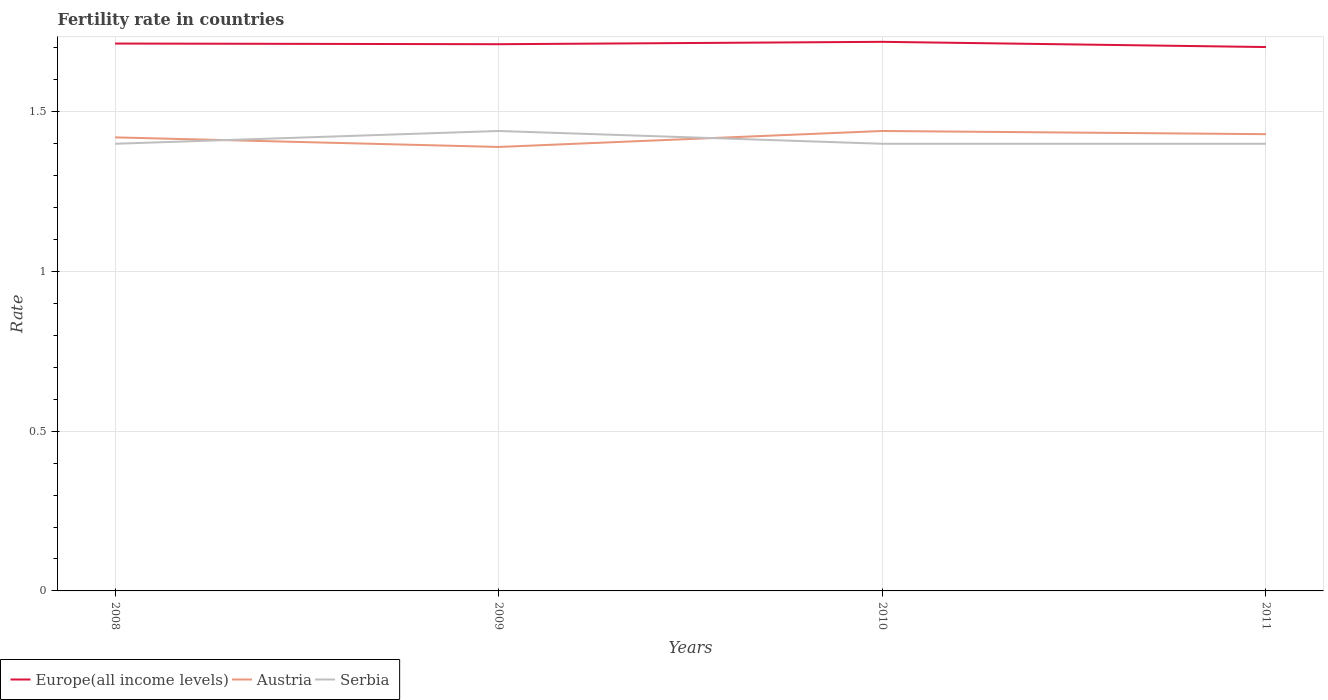Is the number of lines equal to the number of legend labels?
Give a very brief answer. Yes. Across all years, what is the maximum fertility rate in Europe(all income levels)?
Provide a succinct answer. 1.7. What is the total fertility rate in Austria in the graph?
Offer a very short reply. -0.01. What is the difference between the highest and the second highest fertility rate in Serbia?
Your answer should be compact. 0.04. What is the difference between the highest and the lowest fertility rate in Serbia?
Your answer should be compact. 1. How many lines are there?
Your answer should be compact. 3. Does the graph contain any zero values?
Your answer should be compact. No. Does the graph contain grids?
Give a very brief answer. Yes. Where does the legend appear in the graph?
Ensure brevity in your answer.  Bottom left. How many legend labels are there?
Provide a succinct answer. 3. How are the legend labels stacked?
Make the answer very short. Horizontal. What is the title of the graph?
Your response must be concise. Fertility rate in countries. What is the label or title of the X-axis?
Provide a short and direct response. Years. What is the label or title of the Y-axis?
Give a very brief answer. Rate. What is the Rate in Europe(all income levels) in 2008?
Offer a terse response. 1.71. What is the Rate of Austria in 2008?
Offer a very short reply. 1.42. What is the Rate of Europe(all income levels) in 2009?
Keep it short and to the point. 1.71. What is the Rate of Austria in 2009?
Offer a very short reply. 1.39. What is the Rate in Serbia in 2009?
Offer a terse response. 1.44. What is the Rate of Europe(all income levels) in 2010?
Provide a short and direct response. 1.72. What is the Rate of Austria in 2010?
Ensure brevity in your answer.  1.44. What is the Rate of Europe(all income levels) in 2011?
Make the answer very short. 1.7. What is the Rate of Austria in 2011?
Offer a very short reply. 1.43. Across all years, what is the maximum Rate of Europe(all income levels)?
Ensure brevity in your answer.  1.72. Across all years, what is the maximum Rate in Austria?
Your answer should be very brief. 1.44. Across all years, what is the maximum Rate of Serbia?
Offer a terse response. 1.44. Across all years, what is the minimum Rate in Europe(all income levels)?
Provide a short and direct response. 1.7. Across all years, what is the minimum Rate in Austria?
Keep it short and to the point. 1.39. Across all years, what is the minimum Rate of Serbia?
Give a very brief answer. 1.4. What is the total Rate of Europe(all income levels) in the graph?
Your answer should be very brief. 6.85. What is the total Rate of Austria in the graph?
Offer a very short reply. 5.68. What is the total Rate of Serbia in the graph?
Offer a very short reply. 5.64. What is the difference between the Rate of Europe(all income levels) in 2008 and that in 2009?
Your answer should be very brief. 0. What is the difference between the Rate in Serbia in 2008 and that in 2009?
Your answer should be very brief. -0.04. What is the difference between the Rate of Europe(all income levels) in 2008 and that in 2010?
Give a very brief answer. -0.01. What is the difference between the Rate of Austria in 2008 and that in 2010?
Offer a terse response. -0.02. What is the difference between the Rate of Europe(all income levels) in 2008 and that in 2011?
Provide a succinct answer. 0.01. What is the difference between the Rate of Austria in 2008 and that in 2011?
Provide a succinct answer. -0.01. What is the difference between the Rate of Serbia in 2008 and that in 2011?
Provide a short and direct response. 0. What is the difference between the Rate in Europe(all income levels) in 2009 and that in 2010?
Ensure brevity in your answer.  -0.01. What is the difference between the Rate of Austria in 2009 and that in 2010?
Make the answer very short. -0.05. What is the difference between the Rate of Serbia in 2009 and that in 2010?
Your answer should be compact. 0.04. What is the difference between the Rate of Europe(all income levels) in 2009 and that in 2011?
Keep it short and to the point. 0.01. What is the difference between the Rate in Austria in 2009 and that in 2011?
Make the answer very short. -0.04. What is the difference between the Rate in Serbia in 2009 and that in 2011?
Make the answer very short. 0.04. What is the difference between the Rate in Europe(all income levels) in 2010 and that in 2011?
Your answer should be very brief. 0.02. What is the difference between the Rate in Serbia in 2010 and that in 2011?
Provide a succinct answer. 0. What is the difference between the Rate of Europe(all income levels) in 2008 and the Rate of Austria in 2009?
Keep it short and to the point. 0.32. What is the difference between the Rate of Europe(all income levels) in 2008 and the Rate of Serbia in 2009?
Ensure brevity in your answer.  0.27. What is the difference between the Rate of Austria in 2008 and the Rate of Serbia in 2009?
Ensure brevity in your answer.  -0.02. What is the difference between the Rate in Europe(all income levels) in 2008 and the Rate in Austria in 2010?
Offer a very short reply. 0.27. What is the difference between the Rate of Europe(all income levels) in 2008 and the Rate of Serbia in 2010?
Ensure brevity in your answer.  0.31. What is the difference between the Rate of Europe(all income levels) in 2008 and the Rate of Austria in 2011?
Ensure brevity in your answer.  0.28. What is the difference between the Rate of Europe(all income levels) in 2008 and the Rate of Serbia in 2011?
Provide a succinct answer. 0.31. What is the difference between the Rate in Europe(all income levels) in 2009 and the Rate in Austria in 2010?
Ensure brevity in your answer.  0.27. What is the difference between the Rate in Europe(all income levels) in 2009 and the Rate in Serbia in 2010?
Make the answer very short. 0.31. What is the difference between the Rate of Austria in 2009 and the Rate of Serbia in 2010?
Offer a very short reply. -0.01. What is the difference between the Rate of Europe(all income levels) in 2009 and the Rate of Austria in 2011?
Provide a short and direct response. 0.28. What is the difference between the Rate of Europe(all income levels) in 2009 and the Rate of Serbia in 2011?
Offer a very short reply. 0.31. What is the difference between the Rate in Austria in 2009 and the Rate in Serbia in 2011?
Offer a very short reply. -0.01. What is the difference between the Rate of Europe(all income levels) in 2010 and the Rate of Austria in 2011?
Provide a succinct answer. 0.29. What is the difference between the Rate of Europe(all income levels) in 2010 and the Rate of Serbia in 2011?
Make the answer very short. 0.32. What is the difference between the Rate in Austria in 2010 and the Rate in Serbia in 2011?
Offer a very short reply. 0.04. What is the average Rate of Europe(all income levels) per year?
Provide a succinct answer. 1.71. What is the average Rate in Austria per year?
Your response must be concise. 1.42. What is the average Rate in Serbia per year?
Ensure brevity in your answer.  1.41. In the year 2008, what is the difference between the Rate of Europe(all income levels) and Rate of Austria?
Ensure brevity in your answer.  0.29. In the year 2008, what is the difference between the Rate in Europe(all income levels) and Rate in Serbia?
Your response must be concise. 0.31. In the year 2009, what is the difference between the Rate of Europe(all income levels) and Rate of Austria?
Give a very brief answer. 0.32. In the year 2009, what is the difference between the Rate in Europe(all income levels) and Rate in Serbia?
Provide a succinct answer. 0.27. In the year 2009, what is the difference between the Rate of Austria and Rate of Serbia?
Give a very brief answer. -0.05. In the year 2010, what is the difference between the Rate in Europe(all income levels) and Rate in Austria?
Offer a very short reply. 0.28. In the year 2010, what is the difference between the Rate of Europe(all income levels) and Rate of Serbia?
Offer a very short reply. 0.32. In the year 2011, what is the difference between the Rate of Europe(all income levels) and Rate of Austria?
Give a very brief answer. 0.27. In the year 2011, what is the difference between the Rate of Europe(all income levels) and Rate of Serbia?
Keep it short and to the point. 0.3. What is the ratio of the Rate of Europe(all income levels) in 2008 to that in 2009?
Your answer should be compact. 1. What is the ratio of the Rate of Austria in 2008 to that in 2009?
Your answer should be compact. 1.02. What is the ratio of the Rate in Serbia in 2008 to that in 2009?
Provide a short and direct response. 0.97. What is the ratio of the Rate in Europe(all income levels) in 2008 to that in 2010?
Provide a succinct answer. 1. What is the ratio of the Rate in Austria in 2008 to that in 2010?
Make the answer very short. 0.99. What is the ratio of the Rate of Europe(all income levels) in 2008 to that in 2011?
Offer a terse response. 1.01. What is the ratio of the Rate of Serbia in 2008 to that in 2011?
Your answer should be compact. 1. What is the ratio of the Rate in Austria in 2009 to that in 2010?
Give a very brief answer. 0.97. What is the ratio of the Rate of Serbia in 2009 to that in 2010?
Your response must be concise. 1.03. What is the ratio of the Rate in Austria in 2009 to that in 2011?
Your answer should be compact. 0.97. What is the ratio of the Rate of Serbia in 2009 to that in 2011?
Your response must be concise. 1.03. What is the ratio of the Rate of Europe(all income levels) in 2010 to that in 2011?
Keep it short and to the point. 1.01. What is the ratio of the Rate of Austria in 2010 to that in 2011?
Give a very brief answer. 1.01. What is the ratio of the Rate of Serbia in 2010 to that in 2011?
Make the answer very short. 1. What is the difference between the highest and the second highest Rate of Europe(all income levels)?
Your response must be concise. 0.01. What is the difference between the highest and the second highest Rate in Austria?
Your response must be concise. 0.01. What is the difference between the highest and the second highest Rate of Serbia?
Offer a very short reply. 0.04. What is the difference between the highest and the lowest Rate in Europe(all income levels)?
Offer a terse response. 0.02. 